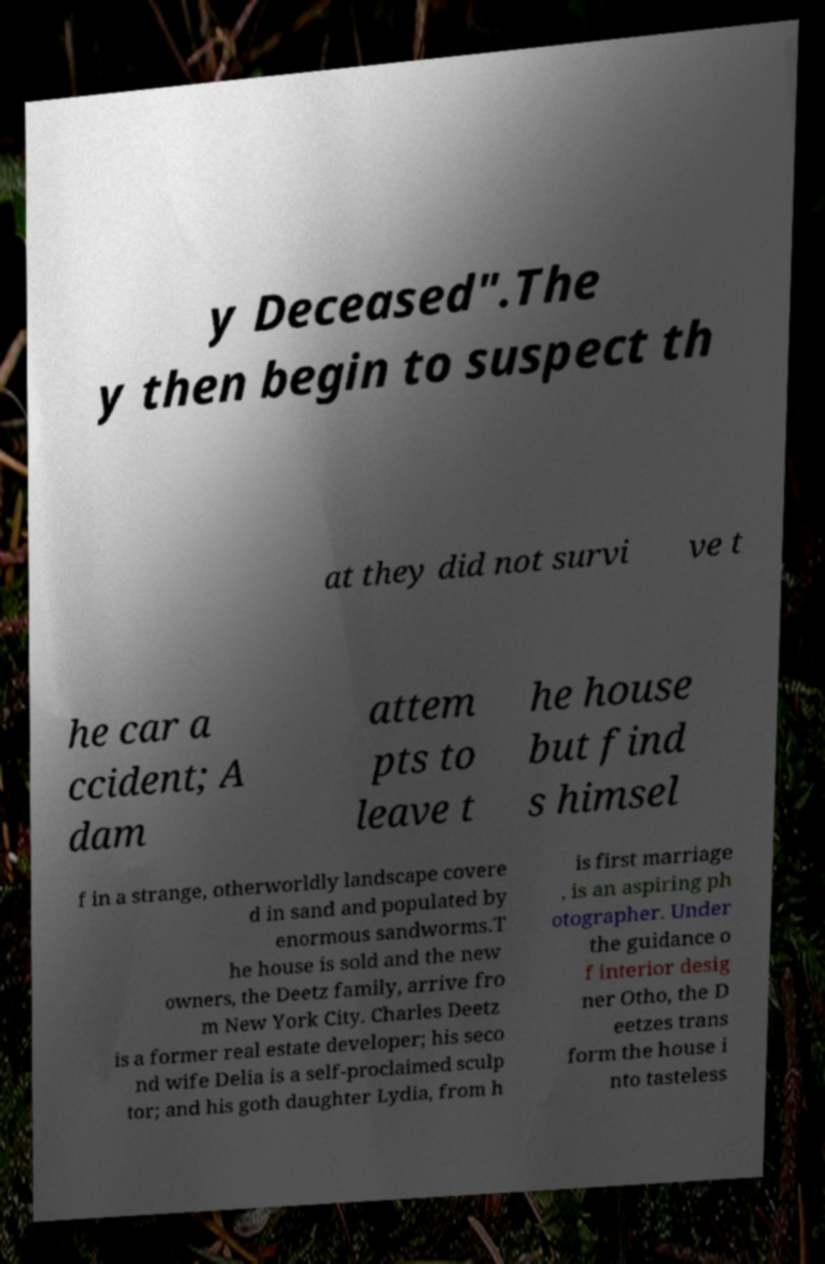What messages or text are displayed in this image? I need them in a readable, typed format. y Deceased".The y then begin to suspect th at they did not survi ve t he car a ccident; A dam attem pts to leave t he house but find s himsel f in a strange, otherworldly landscape covere d in sand and populated by enormous sandworms.T he house is sold and the new owners, the Deetz family, arrive fro m New York City. Charles Deetz is a former real estate developer; his seco nd wife Delia is a self-proclaimed sculp tor; and his goth daughter Lydia, from h is first marriage , is an aspiring ph otographer. Under the guidance o f interior desig ner Otho, the D eetzes trans form the house i nto tasteless 